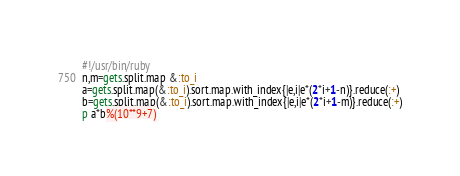Convert code to text. <code><loc_0><loc_0><loc_500><loc_500><_Ruby_>#!/usr/bin/ruby
n,m=gets.split.map &:to_i
a=gets.split.map(&:to_i).sort.map.with_index{|e,i|e*(2*i+1-n)}.reduce(:+)
b=gets.split.map(&:to_i).sort.map.with_index{|e,i|e*(2*i+1-m)}.reduce(:+)
p a*b%(10**9+7)</code> 